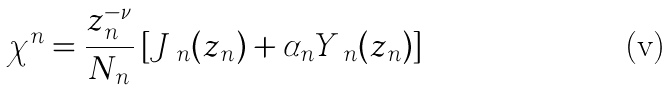Convert formula to latex. <formula><loc_0><loc_0><loc_500><loc_500>\chi ^ { n } = \frac { z _ { n } ^ { - \nu } } { N _ { n } } \left [ J _ { \ n } ( z _ { n } ) + \alpha _ { n } Y _ { \ n } ( z _ { n } ) \right ]</formula> 